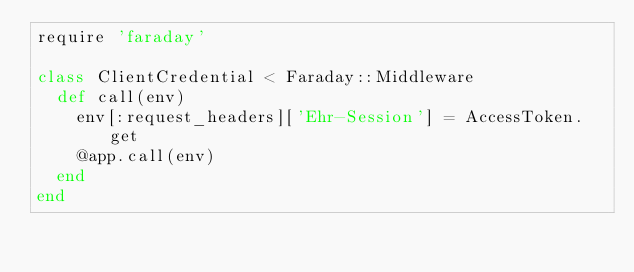<code> <loc_0><loc_0><loc_500><loc_500><_Ruby_>require 'faraday'

class ClientCredential < Faraday::Middleware
  def call(env)
    env[:request_headers]['Ehr-Session'] = AccessToken.get
    @app.call(env)
  end
end
</code> 